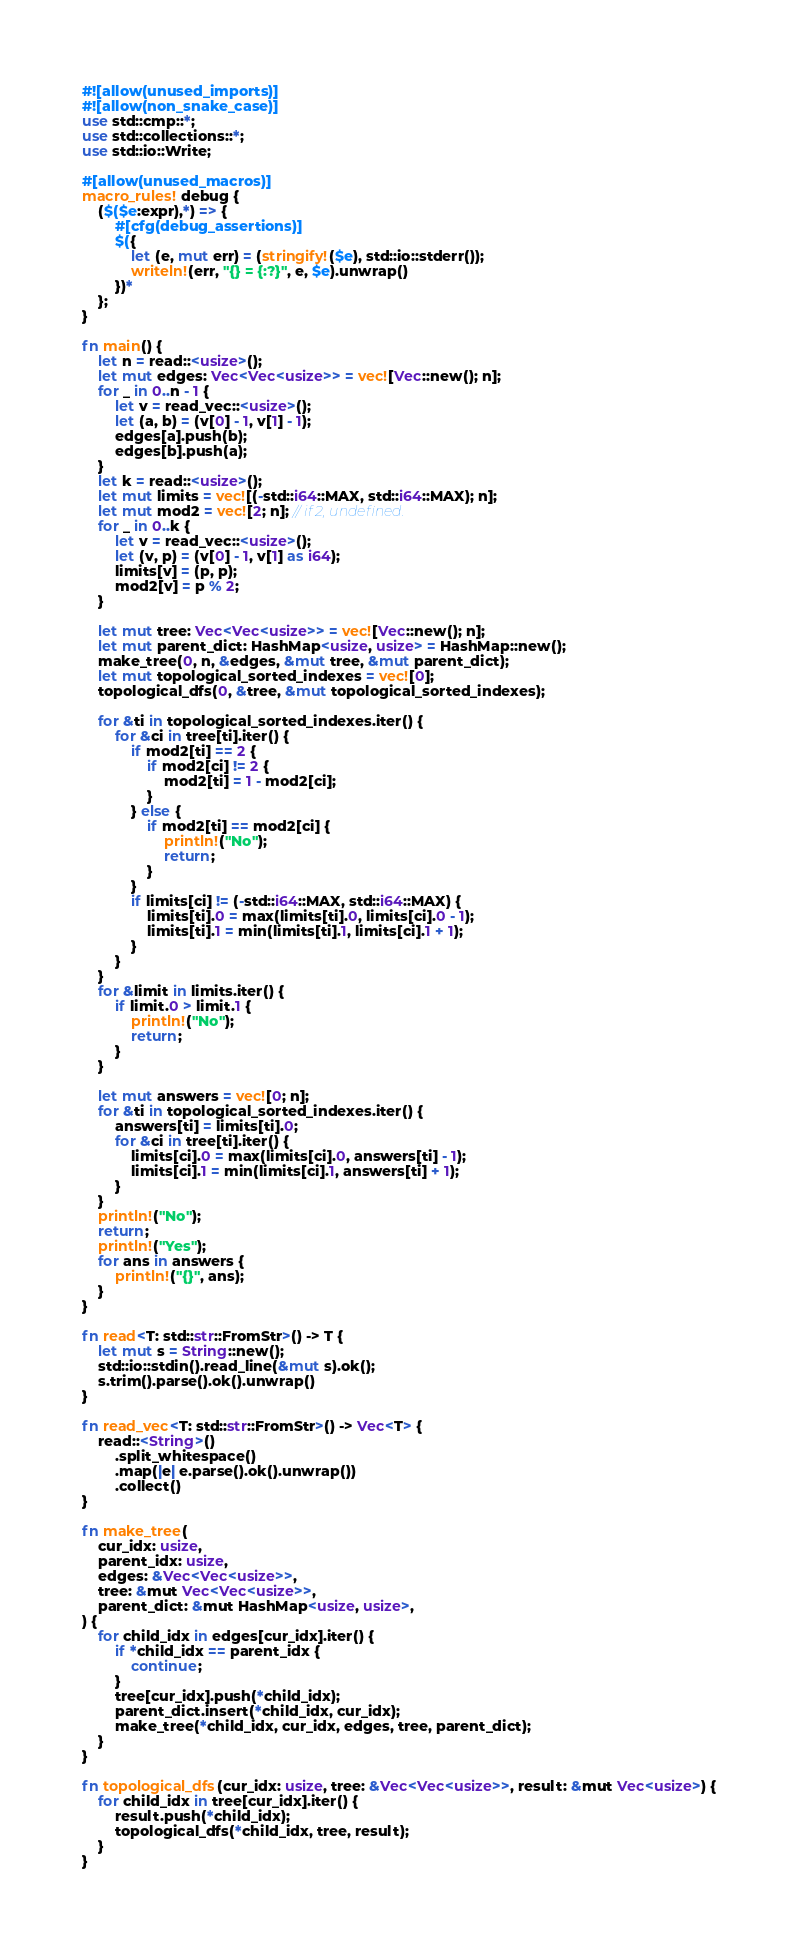<code> <loc_0><loc_0><loc_500><loc_500><_Rust_>#![allow(unused_imports)]
#![allow(non_snake_case)]
use std::cmp::*;
use std::collections::*;
use std::io::Write;

#[allow(unused_macros)]
macro_rules! debug {
    ($($e:expr),*) => {
        #[cfg(debug_assertions)]
        $({
            let (e, mut err) = (stringify!($e), std::io::stderr());
            writeln!(err, "{} = {:?}", e, $e).unwrap()
        })*
    };
}

fn main() {
    let n = read::<usize>();
    let mut edges: Vec<Vec<usize>> = vec![Vec::new(); n];
    for _ in 0..n - 1 {
        let v = read_vec::<usize>();
        let (a, b) = (v[0] - 1, v[1] - 1);
        edges[a].push(b);
        edges[b].push(a);
    }
    let k = read::<usize>();
    let mut limits = vec![(-std::i64::MAX, std::i64::MAX); n];
    let mut mod2 = vec![2; n]; // if 2, undefined.
    for _ in 0..k {
        let v = read_vec::<usize>();
        let (v, p) = (v[0] - 1, v[1] as i64);
        limits[v] = (p, p);
        mod2[v] = p % 2;
    }

    let mut tree: Vec<Vec<usize>> = vec![Vec::new(); n];
    let mut parent_dict: HashMap<usize, usize> = HashMap::new();
    make_tree(0, n, &edges, &mut tree, &mut parent_dict);
    let mut topological_sorted_indexes = vec![0];
    topological_dfs(0, &tree, &mut topological_sorted_indexes);

    for &ti in topological_sorted_indexes.iter() {
        for &ci in tree[ti].iter() {
            if mod2[ti] == 2 {
                if mod2[ci] != 2 {
                    mod2[ti] = 1 - mod2[ci];
                }
            } else {
                if mod2[ti] == mod2[ci] {
                    println!("No");
                    return;
                }
            }
            if limits[ci] != (-std::i64::MAX, std::i64::MAX) {
                limits[ti].0 = max(limits[ti].0, limits[ci].0 - 1);
                limits[ti].1 = min(limits[ti].1, limits[ci].1 + 1);
            }
        }
    }
    for &limit in limits.iter() {
        if limit.0 > limit.1 {
            println!("No");
            return;
        }
    }

    let mut answers = vec![0; n];
    for &ti in topological_sorted_indexes.iter() {
        answers[ti] = limits[ti].0;
        for &ci in tree[ti].iter() {
            limits[ci].0 = max(limits[ci].0, answers[ti] - 1);
            limits[ci].1 = min(limits[ci].1, answers[ti] + 1);
        }
    }
    println!("No");
    return;
    println!("Yes");
    for ans in answers {
        println!("{}", ans);
    }
}

fn read<T: std::str::FromStr>() -> T {
    let mut s = String::new();
    std::io::stdin().read_line(&mut s).ok();
    s.trim().parse().ok().unwrap()
}

fn read_vec<T: std::str::FromStr>() -> Vec<T> {
    read::<String>()
        .split_whitespace()
        .map(|e| e.parse().ok().unwrap())
        .collect()
}

fn make_tree(
    cur_idx: usize,
    parent_idx: usize,
    edges: &Vec<Vec<usize>>,
    tree: &mut Vec<Vec<usize>>,
    parent_dict: &mut HashMap<usize, usize>,
) {
    for child_idx in edges[cur_idx].iter() {
        if *child_idx == parent_idx {
            continue;
        }
        tree[cur_idx].push(*child_idx);
        parent_dict.insert(*child_idx, cur_idx);
        make_tree(*child_idx, cur_idx, edges, tree, parent_dict);
    }
}

fn topological_dfs(cur_idx: usize, tree: &Vec<Vec<usize>>, result: &mut Vec<usize>) {
    for child_idx in tree[cur_idx].iter() {
        result.push(*child_idx);
        topological_dfs(*child_idx, tree, result);
    }
}
</code> 